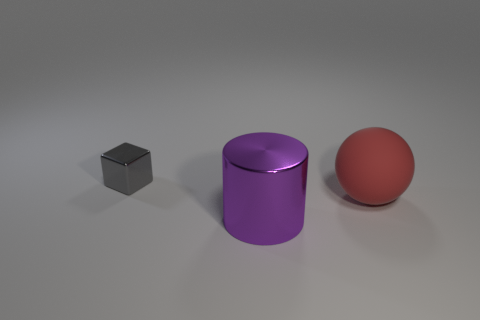Is there any other thing that is the same size as the gray metallic thing?
Your response must be concise. No. Are there any other things that are made of the same material as the tiny gray thing?
Provide a succinct answer. Yes. What size is the metal thing behind the metal thing that is in front of the big matte thing?
Keep it short and to the point. Small. There is a thing that is behind the cylinder and in front of the small object; what color is it?
Give a very brief answer. Red. How many other things are there of the same size as the gray shiny block?
Your response must be concise. 0. Is the size of the metallic cube the same as the metal object in front of the tiny metal thing?
Provide a short and direct response. No. The object that is the same size as the sphere is what color?
Give a very brief answer. Purple. What is the size of the red thing?
Give a very brief answer. Large. Are the object that is on the right side of the big purple metal cylinder and the tiny gray cube made of the same material?
Ensure brevity in your answer.  No. Do the purple shiny object and the big red object have the same shape?
Your response must be concise. No. 